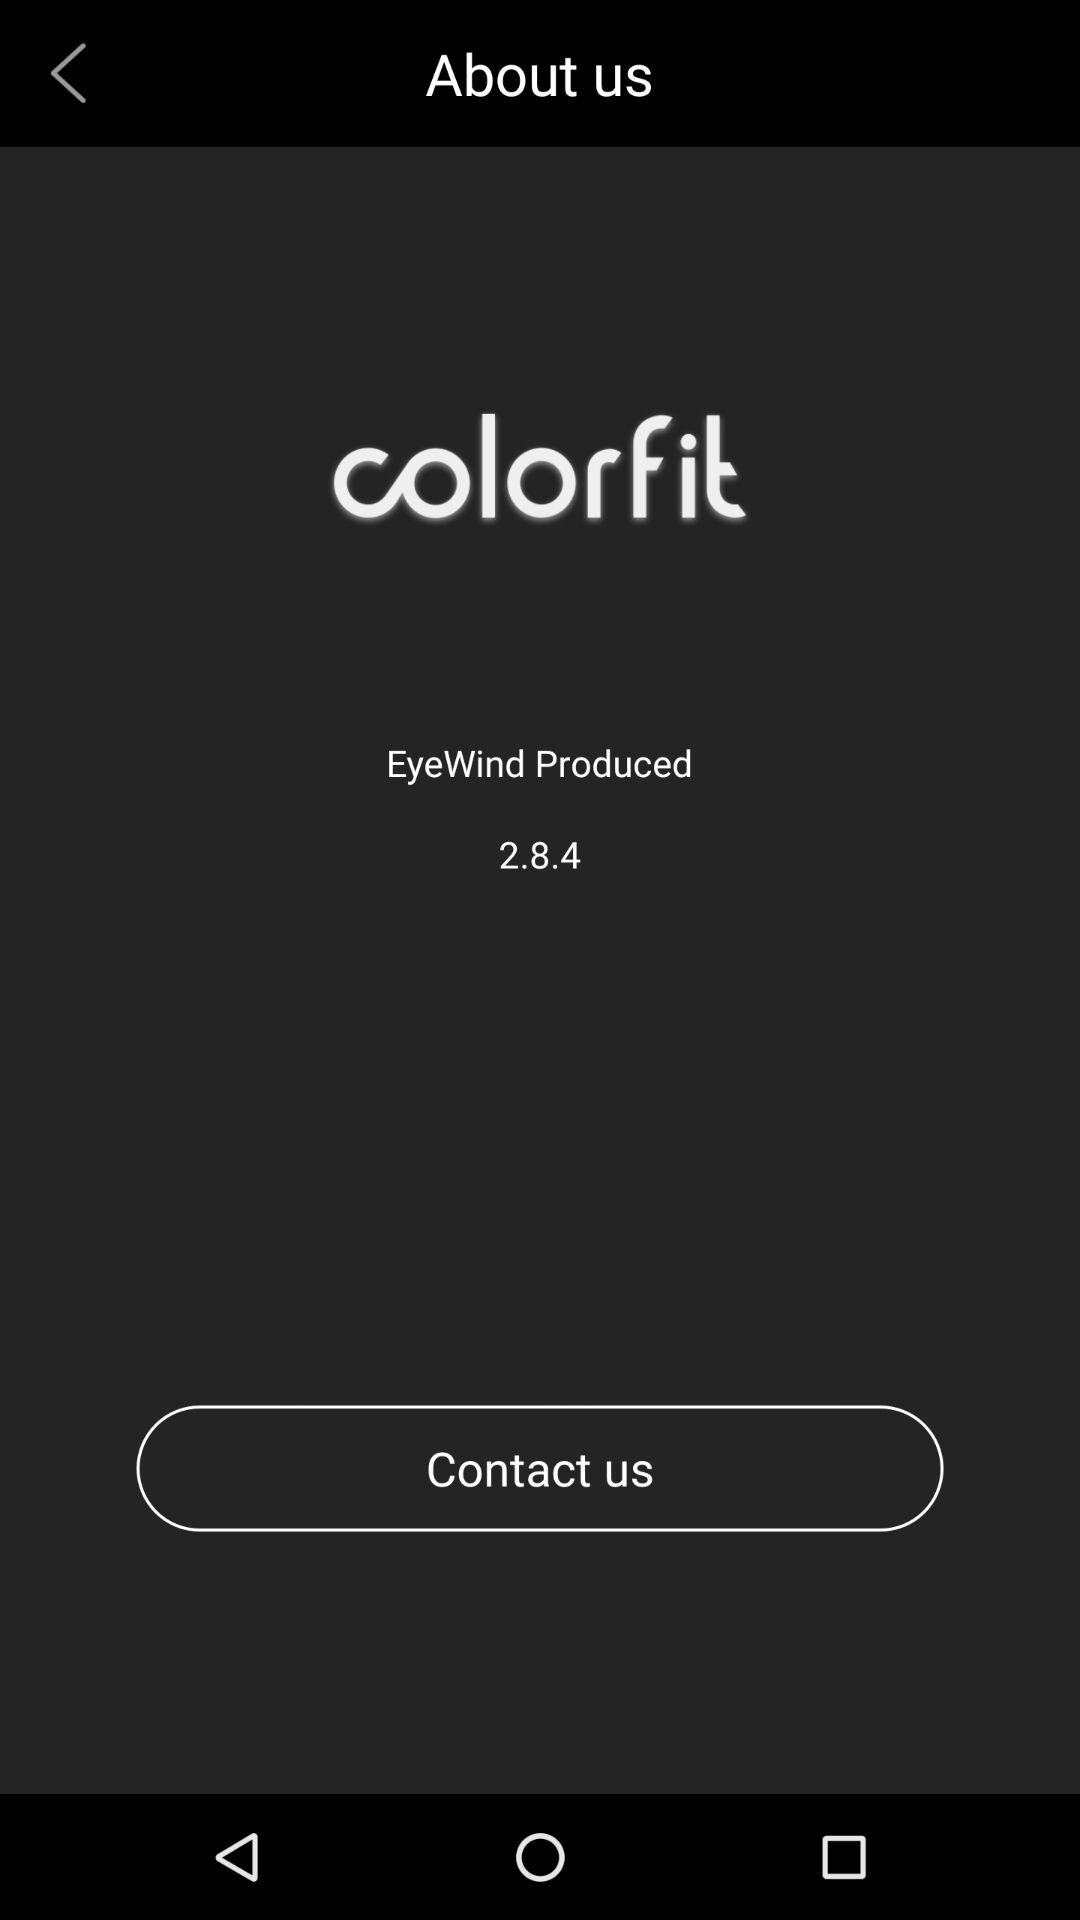What company has developed this application? The company that has developed this application is "EyeWind". 